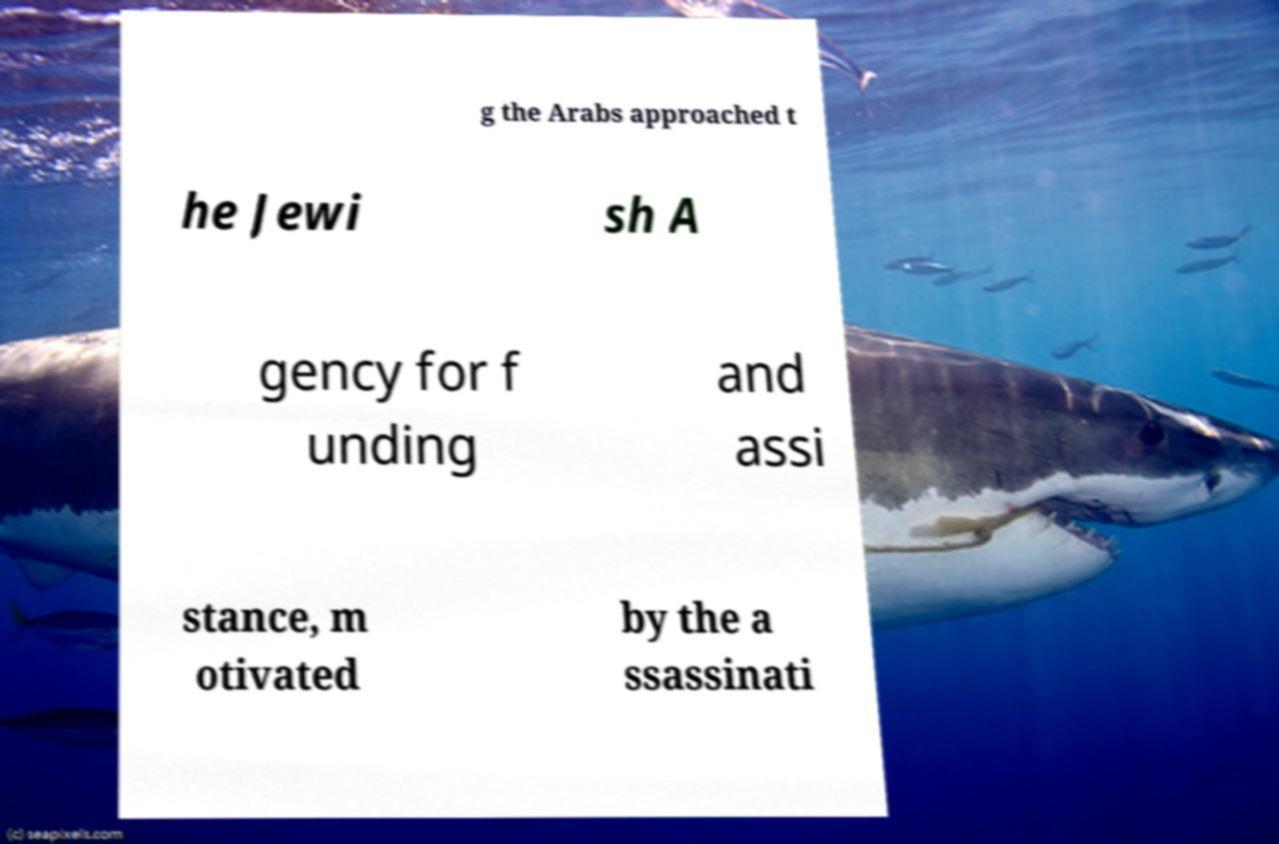Can you read and provide the text displayed in the image?This photo seems to have some interesting text. Can you extract and type it out for me? g the Arabs approached t he Jewi sh A gency for f unding and assi stance, m otivated by the a ssassinati 